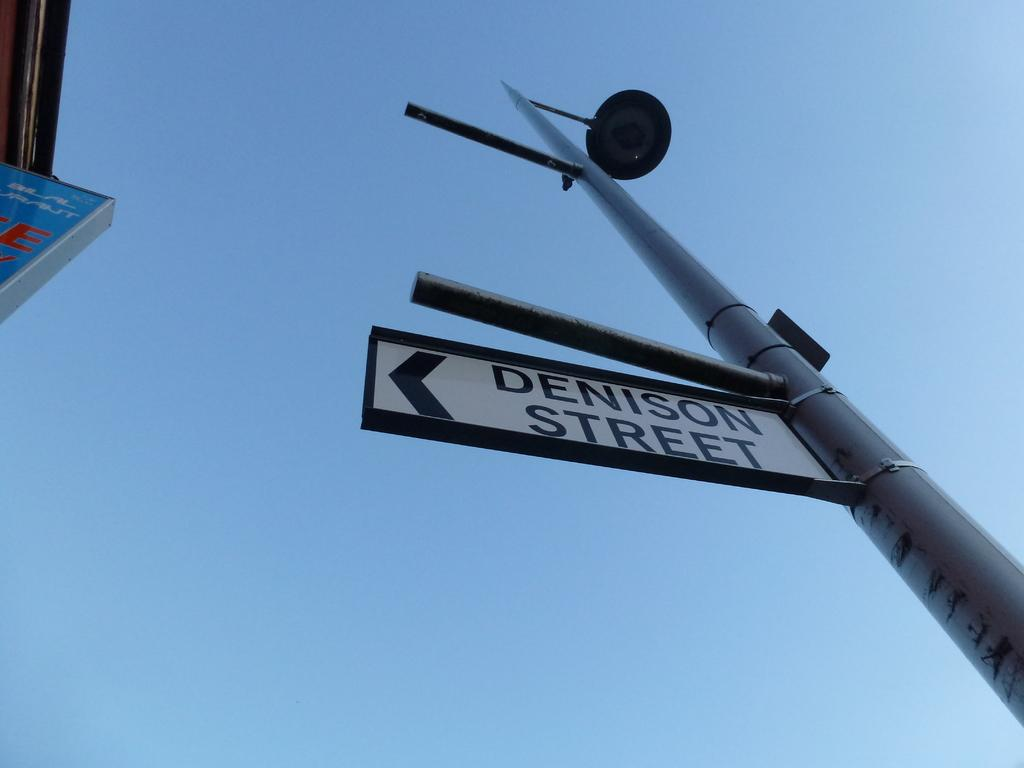Provide a one-sentence caption for the provided image. Street sign that shows Denison Street in black,. 